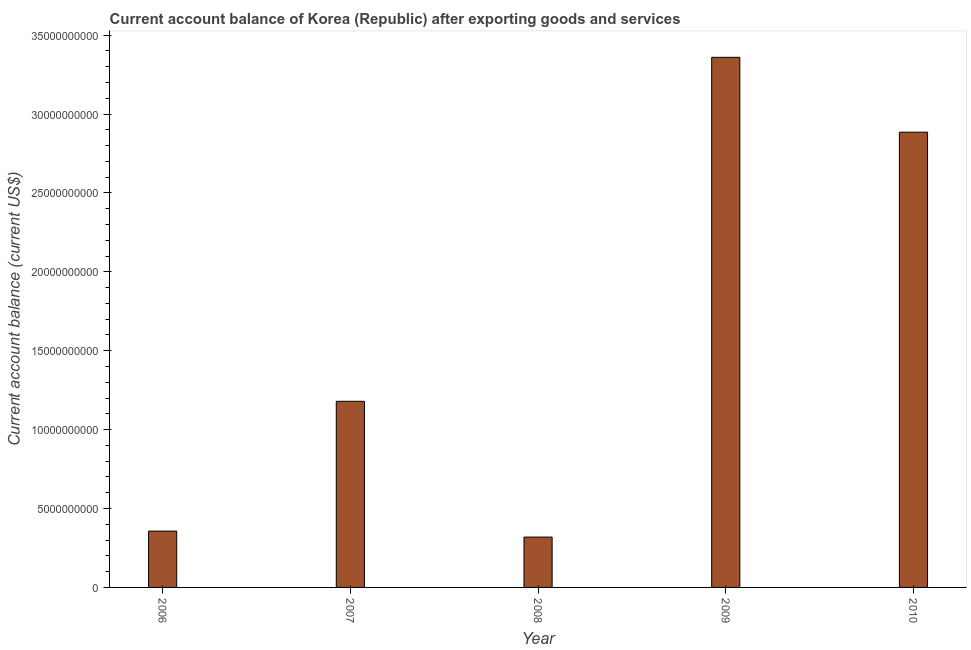Does the graph contain grids?
Offer a terse response. No. What is the title of the graph?
Your answer should be very brief. Current account balance of Korea (Republic) after exporting goods and services. What is the label or title of the X-axis?
Offer a terse response. Year. What is the label or title of the Y-axis?
Your response must be concise. Current account balance (current US$). What is the current account balance in 2010?
Provide a short and direct response. 2.89e+1. Across all years, what is the maximum current account balance?
Your answer should be compact. 3.36e+1. Across all years, what is the minimum current account balance?
Your answer should be very brief. 3.19e+09. What is the sum of the current account balance?
Your answer should be very brief. 8.10e+1. What is the difference between the current account balance in 2006 and 2010?
Provide a short and direct response. -2.53e+1. What is the average current account balance per year?
Provide a succinct answer. 1.62e+1. What is the median current account balance?
Give a very brief answer. 1.18e+1. Do a majority of the years between 2009 and 2006 (inclusive) have current account balance greater than 17000000000 US$?
Ensure brevity in your answer.  Yes. What is the ratio of the current account balance in 2006 to that in 2009?
Offer a very short reply. 0.11. Is the current account balance in 2008 less than that in 2009?
Make the answer very short. Yes. What is the difference between the highest and the second highest current account balance?
Provide a short and direct response. 4.74e+09. Is the sum of the current account balance in 2006 and 2010 greater than the maximum current account balance across all years?
Provide a short and direct response. No. What is the difference between the highest and the lowest current account balance?
Offer a very short reply. 3.04e+1. How many bars are there?
Offer a terse response. 5. Are all the bars in the graph horizontal?
Provide a succinct answer. No. What is the Current account balance (current US$) in 2006?
Provide a succinct answer. 3.57e+09. What is the Current account balance (current US$) of 2007?
Offer a very short reply. 1.18e+1. What is the Current account balance (current US$) in 2008?
Keep it short and to the point. 3.19e+09. What is the Current account balance (current US$) of 2009?
Give a very brief answer. 3.36e+1. What is the Current account balance (current US$) in 2010?
Your answer should be very brief. 2.89e+1. What is the difference between the Current account balance (current US$) in 2006 and 2007?
Keep it short and to the point. -8.23e+09. What is the difference between the Current account balance (current US$) in 2006 and 2008?
Offer a terse response. 3.80e+08. What is the difference between the Current account balance (current US$) in 2006 and 2009?
Ensure brevity in your answer.  -3.00e+1. What is the difference between the Current account balance (current US$) in 2006 and 2010?
Ensure brevity in your answer.  -2.53e+1. What is the difference between the Current account balance (current US$) in 2007 and 2008?
Ensure brevity in your answer.  8.60e+09. What is the difference between the Current account balance (current US$) in 2007 and 2009?
Your answer should be very brief. -2.18e+1. What is the difference between the Current account balance (current US$) in 2007 and 2010?
Your answer should be compact. -1.71e+1. What is the difference between the Current account balance (current US$) in 2008 and 2009?
Offer a very short reply. -3.04e+1. What is the difference between the Current account balance (current US$) in 2008 and 2010?
Keep it short and to the point. -2.57e+1. What is the difference between the Current account balance (current US$) in 2009 and 2010?
Keep it short and to the point. 4.74e+09. What is the ratio of the Current account balance (current US$) in 2006 to that in 2007?
Ensure brevity in your answer.  0.3. What is the ratio of the Current account balance (current US$) in 2006 to that in 2008?
Your response must be concise. 1.12. What is the ratio of the Current account balance (current US$) in 2006 to that in 2009?
Make the answer very short. 0.11. What is the ratio of the Current account balance (current US$) in 2006 to that in 2010?
Your response must be concise. 0.12. What is the ratio of the Current account balance (current US$) in 2007 to that in 2008?
Make the answer very short. 3.7. What is the ratio of the Current account balance (current US$) in 2007 to that in 2009?
Your answer should be very brief. 0.35. What is the ratio of the Current account balance (current US$) in 2007 to that in 2010?
Keep it short and to the point. 0.41. What is the ratio of the Current account balance (current US$) in 2008 to that in 2009?
Ensure brevity in your answer.  0.1. What is the ratio of the Current account balance (current US$) in 2008 to that in 2010?
Your response must be concise. 0.11. What is the ratio of the Current account balance (current US$) in 2009 to that in 2010?
Make the answer very short. 1.16. 